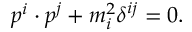Convert formula to latex. <formula><loc_0><loc_0><loc_500><loc_500>p ^ { i } \cdot p ^ { j } + m _ { i } ^ { 2 } \delta ^ { i j } = 0 .</formula> 